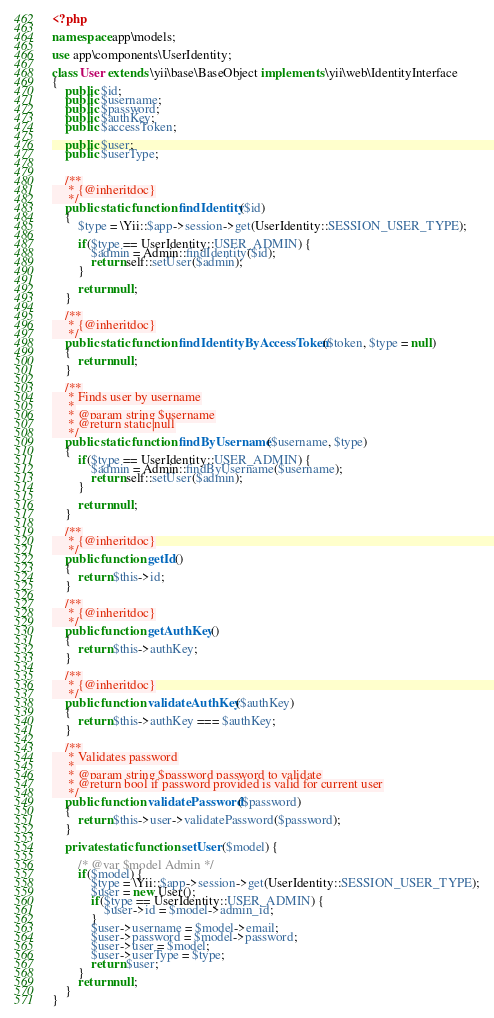Convert code to text. <code><loc_0><loc_0><loc_500><loc_500><_PHP_><?php

namespace app\models;

use app\components\UserIdentity;

class User extends \yii\base\BaseObject implements \yii\web\IdentityInterface
{
    public $id;
    public $username;
    public $password;
    public $authKey;
    public $accessToken;

    public $user;
    public $userType;


    /**
     * {@inheritdoc}
     */
    public static function findIdentity($id)
    {
        $type = \Yii::$app->session->get(UserIdentity::SESSION_USER_TYPE);

        if($type == UserIdentity::USER_ADMIN) {
            $admin = Admin::findIdentity($id);
            return self::setUser($admin);
        }

        return null;
    }

    /**
     * {@inheritdoc}
     */
    public static function findIdentityByAccessToken($token, $type = null)
    {
        return null;
    }

    /**
     * Finds user by username
     *
     * @param string $username
     * @return static|null
     */
    public static function findByUsername($username, $type)
    {
        if($type == UserIdentity::USER_ADMIN) {
            $admin = Admin::findByUsername($username);
            return self::setUser($admin);
        }

        return null;
    }

    /**
     * {@inheritdoc}
     */
    public function getId()
    {
        return $this->id;
    }

    /**
     * {@inheritdoc}
     */
    public function getAuthKey()
    {
        return $this->authKey;
    }

    /**
     * {@inheritdoc}
     */
    public function validateAuthKey($authKey)
    {
        return $this->authKey === $authKey;
    }

    /**
     * Validates password
     *
     * @param string $password password to validate
     * @return bool if password provided is valid for current user
     */
    public function validatePassword($password)
    {
        return $this->user->validatePassword($password);
    }

    private static function setUser($model) {

        /* @var $model Admin */
        if($model) {
            $type = \Yii::$app->session->get(UserIdentity::SESSION_USER_TYPE);
            $user = new User();
            if($type == UserIdentity::USER_ADMIN) {
                $user->id = $model->admin_id;
            }
            $user->username = $model->email;
            $user->password = $model->password;
            $user->user = $model;
            $user->userType = $type;
            return $user;
        }
        return null;
    }
}
</code> 